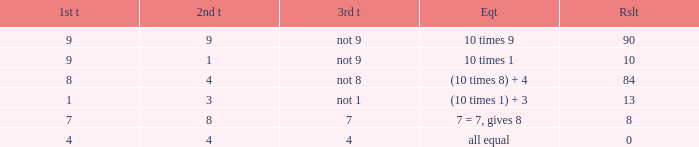If the equation is (10 times 1) + 3, what is the 2nd throw? 3.0. Help me parse the entirety of this table. {'header': ['1st t', '2nd t', '3rd t', 'Eqt', 'Rslt'], 'rows': [['9', '9', 'not 9', '10 times 9', '90'], ['9', '1', 'not 9', '10 times 1', '10'], ['8', '4', 'not 8', '(10 times 8) + 4', '84'], ['1', '3', 'not 1', '(10 times 1) + 3', '13'], ['7', '8', '7', '7 = 7, gives 8', '8'], ['4', '4', '4', 'all equal', '0']]} 